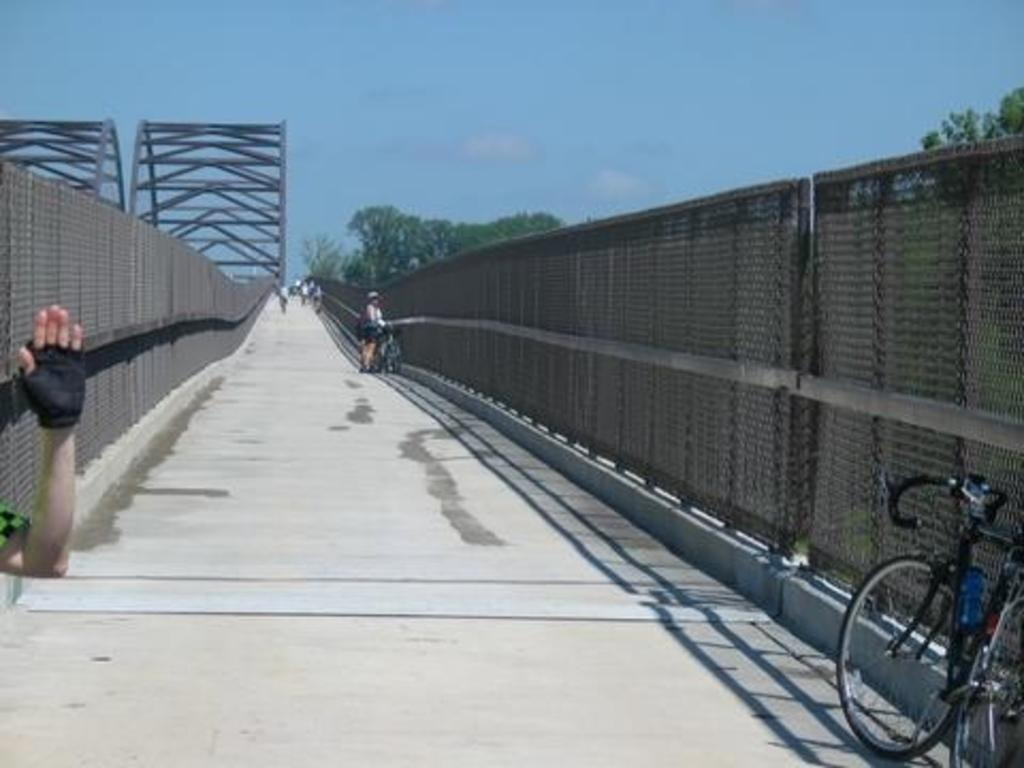How many people are in the image? There are few persons in the image. What can be seen besides the people in the image? There is a bicycle, a fence, trees, and a road in the image. What is the background of the image? There is sky visible in the background of the image. Is there a jail visible in the image? No, there is no jail present in the image. Is it raining in the image? No, there is no indication of rain in the image; the sky is visible in the background. 